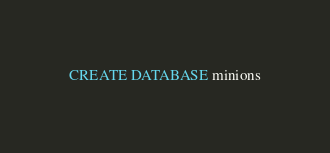<code> <loc_0><loc_0><loc_500><loc_500><_SQL_>CREATE DATABASE minions</code> 